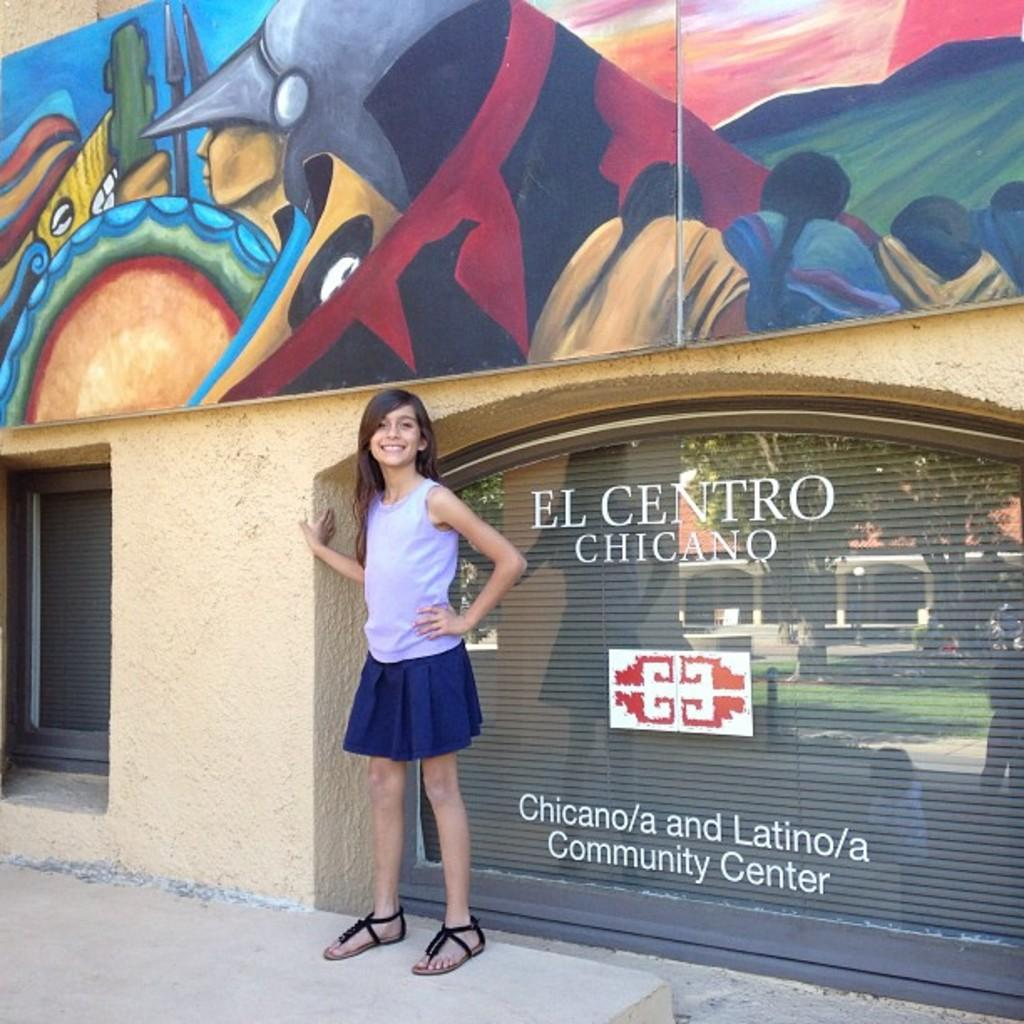<image>
Give a short and clear explanation of the subsequent image. A girl is posing in front of a sign that says El Centro Chicano. 